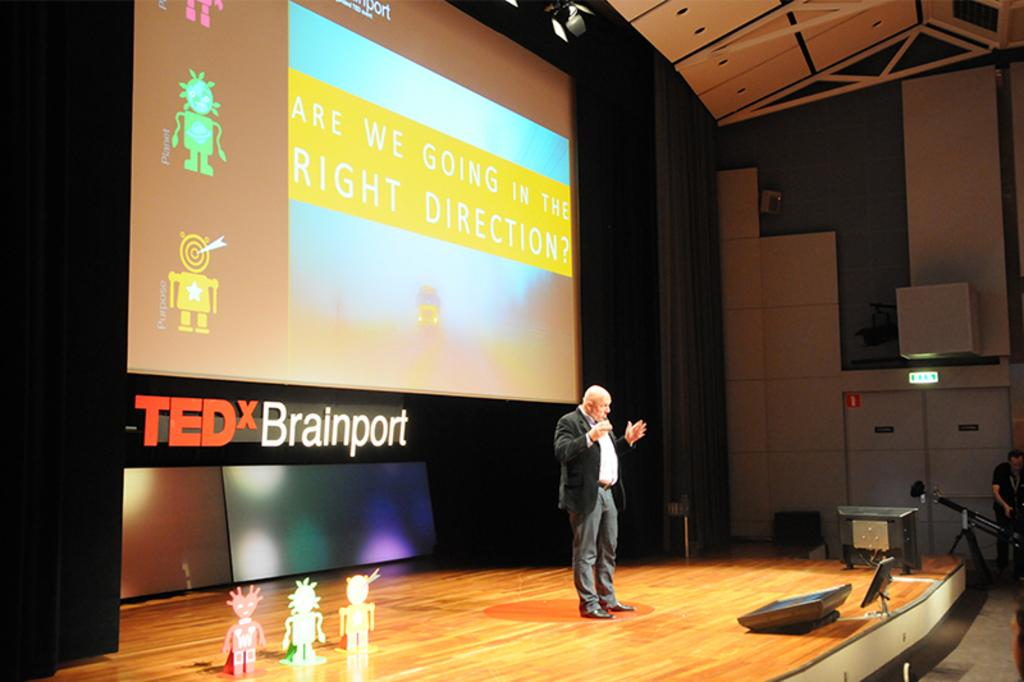<image>
Give a short and clear explanation of the subsequent image. An older gentleman is standing on a large stage, in front of a projection screen that says are we going in the right direction. 